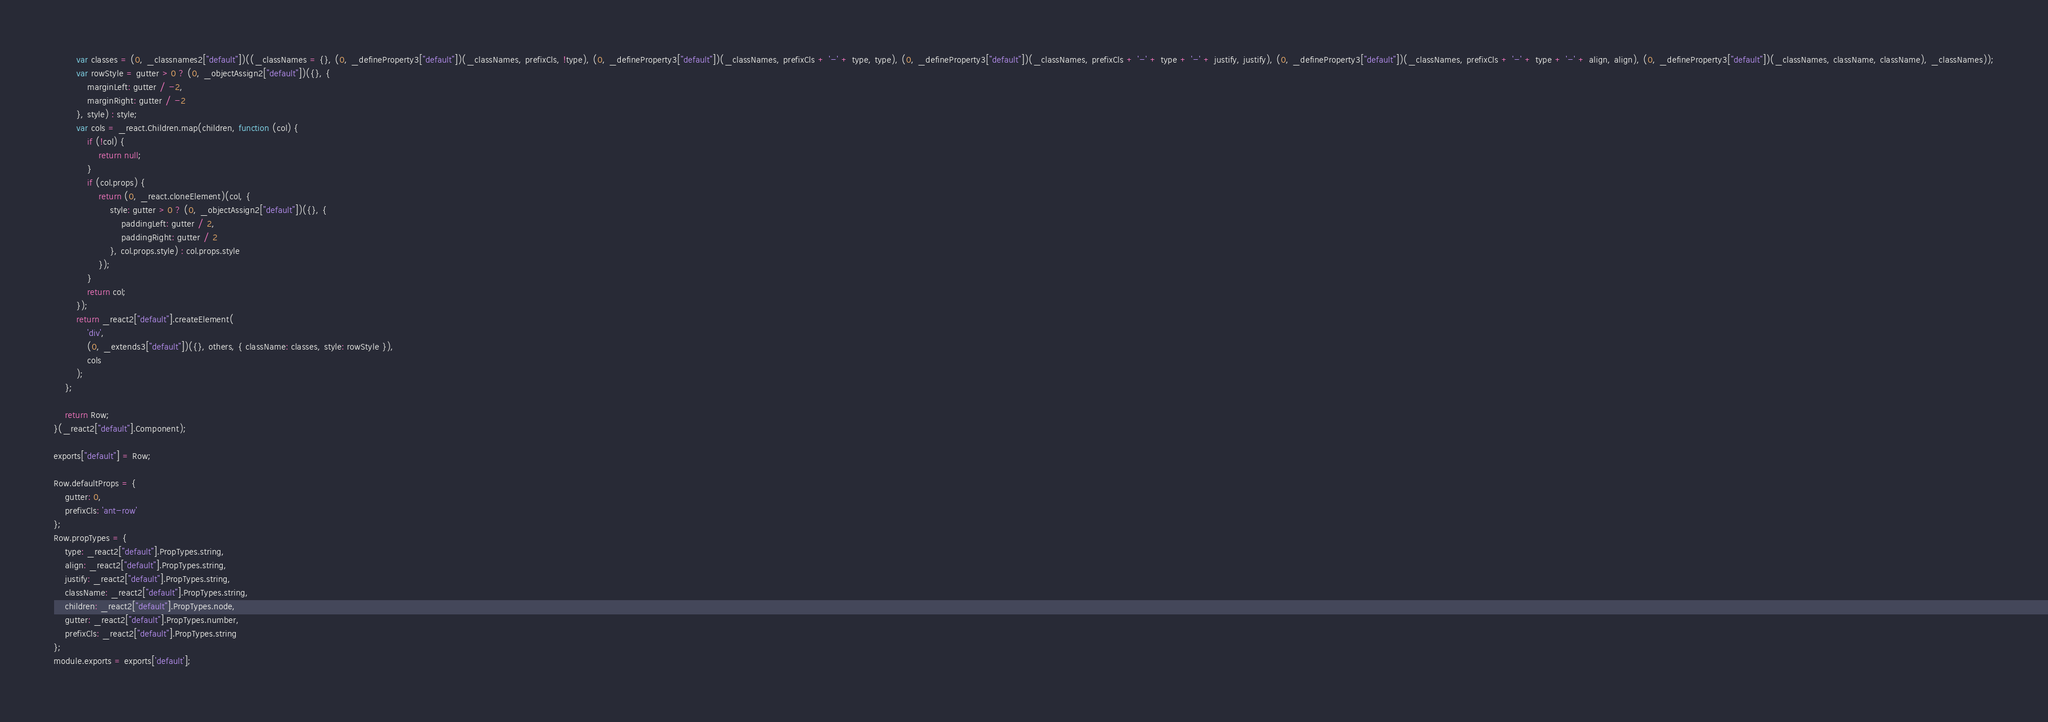<code> <loc_0><loc_0><loc_500><loc_500><_JavaScript_>
        var classes = (0, _classnames2["default"])((_classNames = {}, (0, _defineProperty3["default"])(_classNames, prefixCls, !type), (0, _defineProperty3["default"])(_classNames, prefixCls + '-' + type, type), (0, _defineProperty3["default"])(_classNames, prefixCls + '-' + type + '-' + justify, justify), (0, _defineProperty3["default"])(_classNames, prefixCls + '-' + type + '-' + align, align), (0, _defineProperty3["default"])(_classNames, className, className), _classNames));
        var rowStyle = gutter > 0 ? (0, _objectAssign2["default"])({}, {
            marginLeft: gutter / -2,
            marginRight: gutter / -2
        }, style) : style;
        var cols = _react.Children.map(children, function (col) {
            if (!col) {
                return null;
            }
            if (col.props) {
                return (0, _react.cloneElement)(col, {
                    style: gutter > 0 ? (0, _objectAssign2["default"])({}, {
                        paddingLeft: gutter / 2,
                        paddingRight: gutter / 2
                    }, col.props.style) : col.props.style
                });
            }
            return col;
        });
        return _react2["default"].createElement(
            'div',
            (0, _extends3["default"])({}, others, { className: classes, style: rowStyle }),
            cols
        );
    };

    return Row;
}(_react2["default"].Component);

exports["default"] = Row;

Row.defaultProps = {
    gutter: 0,
    prefixCls: 'ant-row'
};
Row.propTypes = {
    type: _react2["default"].PropTypes.string,
    align: _react2["default"].PropTypes.string,
    justify: _react2["default"].PropTypes.string,
    className: _react2["default"].PropTypes.string,
    children: _react2["default"].PropTypes.node,
    gutter: _react2["default"].PropTypes.number,
    prefixCls: _react2["default"].PropTypes.string
};
module.exports = exports['default'];</code> 